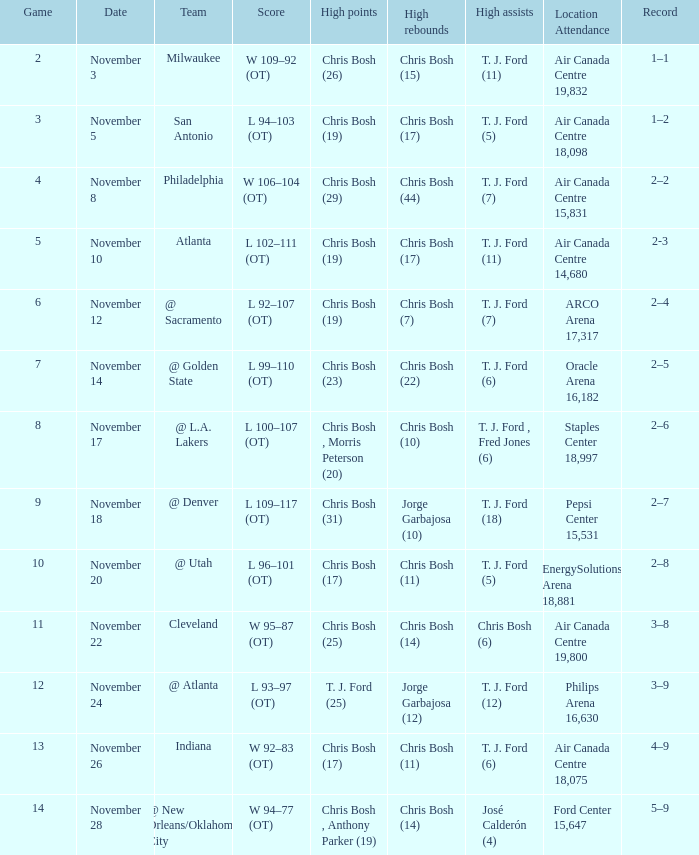Where was the game on November 20? EnergySolutions Arena 18,881. 